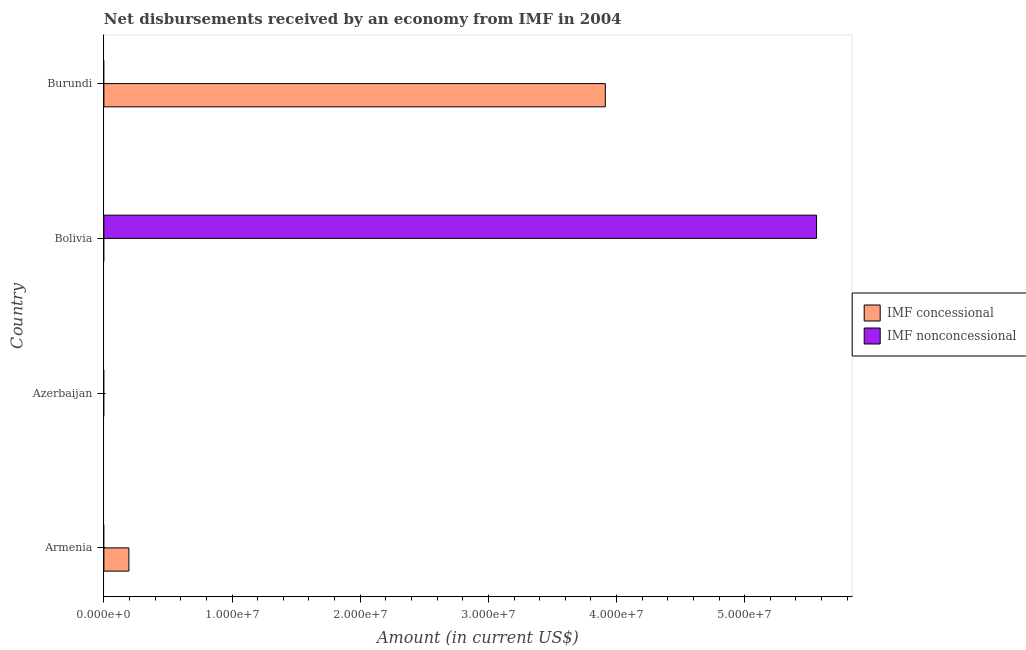How many different coloured bars are there?
Ensure brevity in your answer.  2. Are the number of bars on each tick of the Y-axis equal?
Offer a very short reply. No. How many bars are there on the 1st tick from the top?
Your answer should be compact. 1. What is the label of the 1st group of bars from the top?
Offer a very short reply. Burundi. In how many cases, is the number of bars for a given country not equal to the number of legend labels?
Keep it short and to the point. 4. Across all countries, what is the maximum net concessional disbursements from imf?
Give a very brief answer. 3.91e+07. Across all countries, what is the minimum net concessional disbursements from imf?
Offer a terse response. 0. What is the total net non concessional disbursements from imf in the graph?
Give a very brief answer. 5.56e+07. What is the difference between the net concessional disbursements from imf in Armenia and that in Burundi?
Provide a succinct answer. -3.72e+07. What is the average net non concessional disbursements from imf per country?
Offer a very short reply. 1.39e+07. What is the ratio of the net concessional disbursements from imf in Armenia to that in Burundi?
Your answer should be compact. 0.05. What is the difference between the highest and the lowest net non concessional disbursements from imf?
Offer a terse response. 5.56e+07. In how many countries, is the net non concessional disbursements from imf greater than the average net non concessional disbursements from imf taken over all countries?
Offer a very short reply. 1. How many bars are there?
Make the answer very short. 3. Does the graph contain any zero values?
Provide a succinct answer. Yes. Does the graph contain grids?
Give a very brief answer. No. How many legend labels are there?
Give a very brief answer. 2. What is the title of the graph?
Make the answer very short. Net disbursements received by an economy from IMF in 2004. Does "Commercial service imports" appear as one of the legend labels in the graph?
Your response must be concise. No. What is the label or title of the Y-axis?
Provide a short and direct response. Country. What is the Amount (in current US$) of IMF concessional in Armenia?
Your response must be concise. 1.95e+06. What is the Amount (in current US$) in IMF nonconcessional in Armenia?
Your answer should be very brief. 0. What is the Amount (in current US$) in IMF concessional in Azerbaijan?
Ensure brevity in your answer.  0. What is the Amount (in current US$) in IMF nonconcessional in Azerbaijan?
Ensure brevity in your answer.  0. What is the Amount (in current US$) of IMF nonconcessional in Bolivia?
Your response must be concise. 5.56e+07. What is the Amount (in current US$) of IMF concessional in Burundi?
Your answer should be compact. 3.91e+07. What is the Amount (in current US$) of IMF nonconcessional in Burundi?
Your response must be concise. 0. Across all countries, what is the maximum Amount (in current US$) of IMF concessional?
Ensure brevity in your answer.  3.91e+07. Across all countries, what is the maximum Amount (in current US$) of IMF nonconcessional?
Provide a succinct answer. 5.56e+07. Across all countries, what is the minimum Amount (in current US$) of IMF concessional?
Your answer should be very brief. 0. Across all countries, what is the minimum Amount (in current US$) in IMF nonconcessional?
Offer a very short reply. 0. What is the total Amount (in current US$) in IMF concessional in the graph?
Provide a short and direct response. 4.11e+07. What is the total Amount (in current US$) of IMF nonconcessional in the graph?
Provide a succinct answer. 5.56e+07. What is the difference between the Amount (in current US$) in IMF concessional in Armenia and that in Burundi?
Your answer should be very brief. -3.72e+07. What is the difference between the Amount (in current US$) of IMF concessional in Armenia and the Amount (in current US$) of IMF nonconcessional in Bolivia?
Offer a very short reply. -5.37e+07. What is the average Amount (in current US$) of IMF concessional per country?
Ensure brevity in your answer.  1.03e+07. What is the average Amount (in current US$) in IMF nonconcessional per country?
Your answer should be compact. 1.39e+07. What is the ratio of the Amount (in current US$) in IMF concessional in Armenia to that in Burundi?
Provide a succinct answer. 0.05. What is the difference between the highest and the lowest Amount (in current US$) in IMF concessional?
Your response must be concise. 3.91e+07. What is the difference between the highest and the lowest Amount (in current US$) of IMF nonconcessional?
Your answer should be compact. 5.56e+07. 